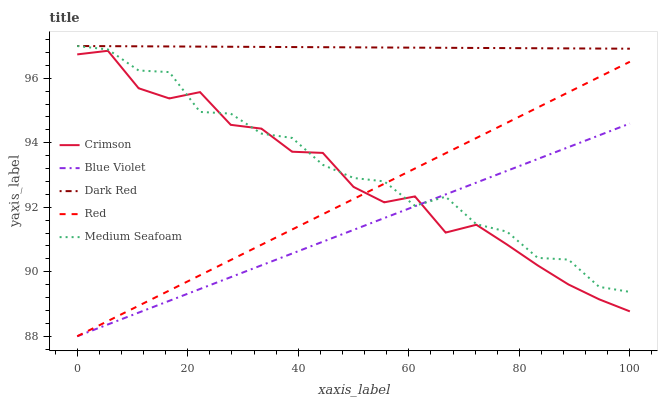Does Blue Violet have the minimum area under the curve?
Answer yes or no. Yes. Does Dark Red have the maximum area under the curve?
Answer yes or no. Yes. Does Red have the minimum area under the curve?
Answer yes or no. No. Does Red have the maximum area under the curve?
Answer yes or no. No. Is Red the smoothest?
Answer yes or no. Yes. Is Medium Seafoam the roughest?
Answer yes or no. Yes. Is Dark Red the smoothest?
Answer yes or no. No. Is Dark Red the roughest?
Answer yes or no. No. Does Red have the lowest value?
Answer yes or no. Yes. Does Dark Red have the lowest value?
Answer yes or no. No. Does Medium Seafoam have the highest value?
Answer yes or no. Yes. Does Red have the highest value?
Answer yes or no. No. Is Blue Violet less than Dark Red?
Answer yes or no. Yes. Is Dark Red greater than Blue Violet?
Answer yes or no. Yes. Does Blue Violet intersect Red?
Answer yes or no. Yes. Is Blue Violet less than Red?
Answer yes or no. No. Is Blue Violet greater than Red?
Answer yes or no. No. Does Blue Violet intersect Dark Red?
Answer yes or no. No. 